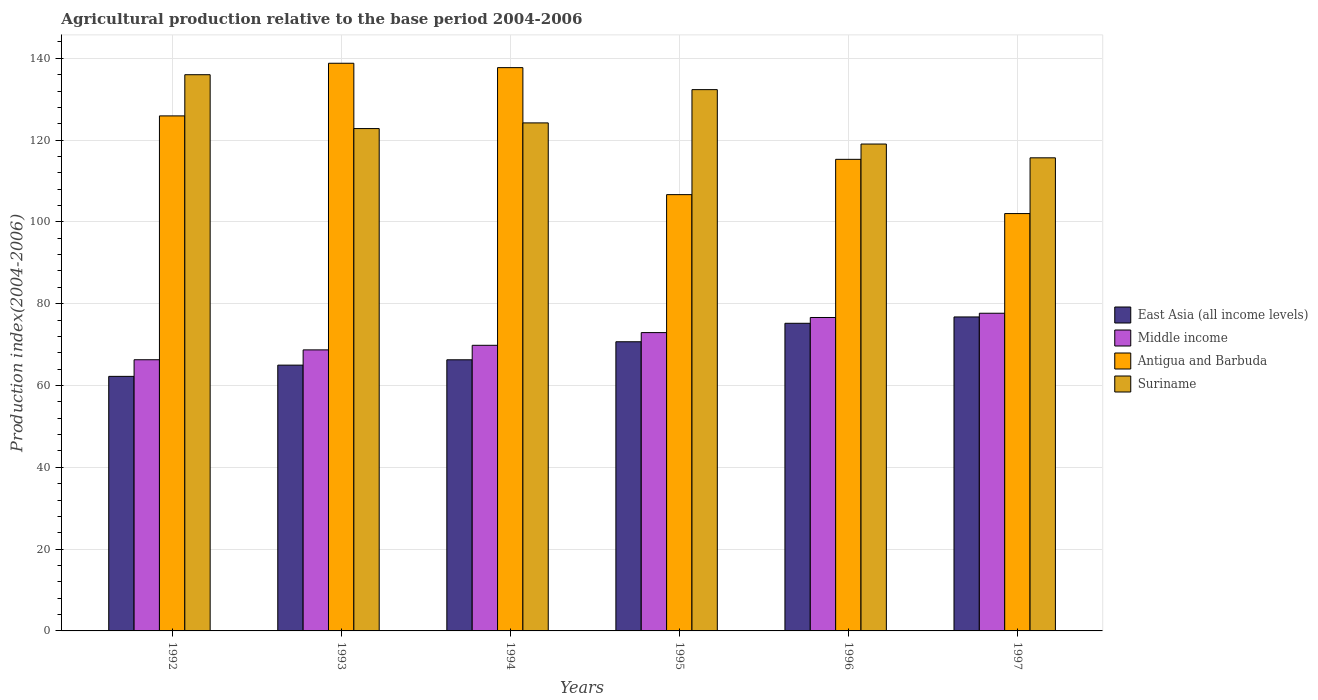How many different coloured bars are there?
Provide a succinct answer. 4. Are the number of bars on each tick of the X-axis equal?
Your response must be concise. Yes. How many bars are there on the 5th tick from the right?
Ensure brevity in your answer.  4. In how many cases, is the number of bars for a given year not equal to the number of legend labels?
Your answer should be compact. 0. What is the agricultural production index in Suriname in 1995?
Make the answer very short. 132.34. Across all years, what is the maximum agricultural production index in Antigua and Barbuda?
Offer a very short reply. 138.79. Across all years, what is the minimum agricultural production index in Antigua and Barbuda?
Keep it short and to the point. 102.04. In which year was the agricultural production index in Antigua and Barbuda maximum?
Ensure brevity in your answer.  1993. In which year was the agricultural production index in Antigua and Barbuda minimum?
Keep it short and to the point. 1997. What is the total agricultural production index in Middle income in the graph?
Offer a very short reply. 432.08. What is the difference between the agricultural production index in Suriname in 1993 and that in 1994?
Give a very brief answer. -1.39. What is the difference between the agricultural production index in East Asia (all income levels) in 1993 and the agricultural production index in Middle income in 1997?
Offer a very short reply. -12.69. What is the average agricultural production index in Middle income per year?
Offer a terse response. 72.01. In the year 1996, what is the difference between the agricultural production index in Suriname and agricultural production index in East Asia (all income levels)?
Ensure brevity in your answer.  43.83. In how many years, is the agricultural production index in East Asia (all income levels) greater than 8?
Your response must be concise. 6. What is the ratio of the agricultural production index in East Asia (all income levels) in 1992 to that in 1996?
Provide a succinct answer. 0.83. Is the difference between the agricultural production index in Suriname in 1994 and 1996 greater than the difference between the agricultural production index in East Asia (all income levels) in 1994 and 1996?
Offer a terse response. Yes. What is the difference between the highest and the second highest agricultural production index in Middle income?
Offer a terse response. 1.04. What is the difference between the highest and the lowest agricultural production index in East Asia (all income levels)?
Ensure brevity in your answer.  14.53. What does the 1st bar from the left in 1997 represents?
Provide a short and direct response. East Asia (all income levels). What does the 4th bar from the right in 1993 represents?
Offer a very short reply. East Asia (all income levels). How many bars are there?
Make the answer very short. 24. Does the graph contain grids?
Give a very brief answer. Yes. How many legend labels are there?
Give a very brief answer. 4. What is the title of the graph?
Provide a succinct answer. Agricultural production relative to the base period 2004-2006. What is the label or title of the Y-axis?
Offer a terse response. Production index(2004-2006). What is the Production index(2004-2006) in East Asia (all income levels) in 1992?
Provide a short and direct response. 62.24. What is the Production index(2004-2006) in Middle income in 1992?
Offer a terse response. 66.3. What is the Production index(2004-2006) of Antigua and Barbuda in 1992?
Ensure brevity in your answer.  125.92. What is the Production index(2004-2006) in Suriname in 1992?
Offer a very short reply. 135.99. What is the Production index(2004-2006) of East Asia (all income levels) in 1993?
Provide a succinct answer. 64.98. What is the Production index(2004-2006) in Middle income in 1993?
Offer a terse response. 68.71. What is the Production index(2004-2006) of Antigua and Barbuda in 1993?
Ensure brevity in your answer.  138.79. What is the Production index(2004-2006) of Suriname in 1993?
Your answer should be compact. 122.82. What is the Production index(2004-2006) in East Asia (all income levels) in 1994?
Offer a very short reply. 66.29. What is the Production index(2004-2006) in Middle income in 1994?
Keep it short and to the point. 69.83. What is the Production index(2004-2006) in Antigua and Barbuda in 1994?
Your answer should be compact. 137.72. What is the Production index(2004-2006) of Suriname in 1994?
Your answer should be compact. 124.21. What is the Production index(2004-2006) in East Asia (all income levels) in 1995?
Your answer should be very brief. 70.7. What is the Production index(2004-2006) of Middle income in 1995?
Your answer should be very brief. 72.94. What is the Production index(2004-2006) of Antigua and Barbuda in 1995?
Provide a short and direct response. 106.67. What is the Production index(2004-2006) in Suriname in 1995?
Keep it short and to the point. 132.34. What is the Production index(2004-2006) of East Asia (all income levels) in 1996?
Your response must be concise. 75.21. What is the Production index(2004-2006) of Middle income in 1996?
Offer a terse response. 76.63. What is the Production index(2004-2006) in Antigua and Barbuda in 1996?
Provide a succinct answer. 115.3. What is the Production index(2004-2006) of Suriname in 1996?
Provide a short and direct response. 119.04. What is the Production index(2004-2006) of East Asia (all income levels) in 1997?
Provide a succinct answer. 76.76. What is the Production index(2004-2006) of Middle income in 1997?
Keep it short and to the point. 77.67. What is the Production index(2004-2006) of Antigua and Barbuda in 1997?
Offer a terse response. 102.04. What is the Production index(2004-2006) of Suriname in 1997?
Offer a very short reply. 115.67. Across all years, what is the maximum Production index(2004-2006) in East Asia (all income levels)?
Provide a short and direct response. 76.76. Across all years, what is the maximum Production index(2004-2006) of Middle income?
Provide a short and direct response. 77.67. Across all years, what is the maximum Production index(2004-2006) in Antigua and Barbuda?
Your answer should be very brief. 138.79. Across all years, what is the maximum Production index(2004-2006) in Suriname?
Your answer should be very brief. 135.99. Across all years, what is the minimum Production index(2004-2006) in East Asia (all income levels)?
Your response must be concise. 62.24. Across all years, what is the minimum Production index(2004-2006) of Middle income?
Your answer should be very brief. 66.3. Across all years, what is the minimum Production index(2004-2006) in Antigua and Barbuda?
Your answer should be compact. 102.04. Across all years, what is the minimum Production index(2004-2006) in Suriname?
Your answer should be compact. 115.67. What is the total Production index(2004-2006) of East Asia (all income levels) in the graph?
Your answer should be compact. 416.18. What is the total Production index(2004-2006) in Middle income in the graph?
Your response must be concise. 432.08. What is the total Production index(2004-2006) of Antigua and Barbuda in the graph?
Provide a succinct answer. 726.44. What is the total Production index(2004-2006) in Suriname in the graph?
Offer a terse response. 750.07. What is the difference between the Production index(2004-2006) in East Asia (all income levels) in 1992 and that in 1993?
Give a very brief answer. -2.75. What is the difference between the Production index(2004-2006) of Middle income in 1992 and that in 1993?
Ensure brevity in your answer.  -2.41. What is the difference between the Production index(2004-2006) in Antigua and Barbuda in 1992 and that in 1993?
Give a very brief answer. -12.87. What is the difference between the Production index(2004-2006) in Suriname in 1992 and that in 1993?
Keep it short and to the point. 13.17. What is the difference between the Production index(2004-2006) of East Asia (all income levels) in 1992 and that in 1994?
Your answer should be very brief. -4.05. What is the difference between the Production index(2004-2006) in Middle income in 1992 and that in 1994?
Provide a short and direct response. -3.53. What is the difference between the Production index(2004-2006) in Suriname in 1992 and that in 1994?
Ensure brevity in your answer.  11.78. What is the difference between the Production index(2004-2006) in East Asia (all income levels) in 1992 and that in 1995?
Make the answer very short. -8.46. What is the difference between the Production index(2004-2006) of Middle income in 1992 and that in 1995?
Offer a terse response. -6.64. What is the difference between the Production index(2004-2006) in Antigua and Barbuda in 1992 and that in 1995?
Provide a short and direct response. 19.25. What is the difference between the Production index(2004-2006) in Suriname in 1992 and that in 1995?
Offer a terse response. 3.65. What is the difference between the Production index(2004-2006) of East Asia (all income levels) in 1992 and that in 1996?
Make the answer very short. -12.98. What is the difference between the Production index(2004-2006) in Middle income in 1992 and that in 1996?
Keep it short and to the point. -10.33. What is the difference between the Production index(2004-2006) in Antigua and Barbuda in 1992 and that in 1996?
Provide a succinct answer. 10.62. What is the difference between the Production index(2004-2006) of Suriname in 1992 and that in 1996?
Provide a short and direct response. 16.95. What is the difference between the Production index(2004-2006) of East Asia (all income levels) in 1992 and that in 1997?
Make the answer very short. -14.53. What is the difference between the Production index(2004-2006) in Middle income in 1992 and that in 1997?
Offer a terse response. -11.37. What is the difference between the Production index(2004-2006) in Antigua and Barbuda in 1992 and that in 1997?
Provide a short and direct response. 23.88. What is the difference between the Production index(2004-2006) of Suriname in 1992 and that in 1997?
Make the answer very short. 20.32. What is the difference between the Production index(2004-2006) in East Asia (all income levels) in 1993 and that in 1994?
Make the answer very short. -1.3. What is the difference between the Production index(2004-2006) of Middle income in 1993 and that in 1994?
Provide a succinct answer. -1.12. What is the difference between the Production index(2004-2006) of Antigua and Barbuda in 1993 and that in 1994?
Ensure brevity in your answer.  1.07. What is the difference between the Production index(2004-2006) in Suriname in 1993 and that in 1994?
Make the answer very short. -1.39. What is the difference between the Production index(2004-2006) in East Asia (all income levels) in 1993 and that in 1995?
Your answer should be very brief. -5.71. What is the difference between the Production index(2004-2006) of Middle income in 1993 and that in 1995?
Your answer should be compact. -4.22. What is the difference between the Production index(2004-2006) of Antigua and Barbuda in 1993 and that in 1995?
Provide a succinct answer. 32.12. What is the difference between the Production index(2004-2006) of Suriname in 1993 and that in 1995?
Your answer should be compact. -9.52. What is the difference between the Production index(2004-2006) in East Asia (all income levels) in 1993 and that in 1996?
Your answer should be very brief. -10.23. What is the difference between the Production index(2004-2006) in Middle income in 1993 and that in 1996?
Offer a terse response. -7.92. What is the difference between the Production index(2004-2006) of Antigua and Barbuda in 1993 and that in 1996?
Give a very brief answer. 23.49. What is the difference between the Production index(2004-2006) of Suriname in 1993 and that in 1996?
Your response must be concise. 3.78. What is the difference between the Production index(2004-2006) in East Asia (all income levels) in 1993 and that in 1997?
Provide a succinct answer. -11.78. What is the difference between the Production index(2004-2006) in Middle income in 1993 and that in 1997?
Offer a terse response. -8.96. What is the difference between the Production index(2004-2006) of Antigua and Barbuda in 1993 and that in 1997?
Your answer should be very brief. 36.75. What is the difference between the Production index(2004-2006) in Suriname in 1993 and that in 1997?
Ensure brevity in your answer.  7.15. What is the difference between the Production index(2004-2006) in East Asia (all income levels) in 1994 and that in 1995?
Provide a short and direct response. -4.41. What is the difference between the Production index(2004-2006) in Middle income in 1994 and that in 1995?
Ensure brevity in your answer.  -3.11. What is the difference between the Production index(2004-2006) of Antigua and Barbuda in 1994 and that in 1995?
Your answer should be compact. 31.05. What is the difference between the Production index(2004-2006) of Suriname in 1994 and that in 1995?
Make the answer very short. -8.13. What is the difference between the Production index(2004-2006) in East Asia (all income levels) in 1994 and that in 1996?
Keep it short and to the point. -8.93. What is the difference between the Production index(2004-2006) of Middle income in 1994 and that in 1996?
Provide a succinct answer. -6.8. What is the difference between the Production index(2004-2006) of Antigua and Barbuda in 1994 and that in 1996?
Ensure brevity in your answer.  22.42. What is the difference between the Production index(2004-2006) in Suriname in 1994 and that in 1996?
Your response must be concise. 5.17. What is the difference between the Production index(2004-2006) in East Asia (all income levels) in 1994 and that in 1997?
Your answer should be very brief. -10.47. What is the difference between the Production index(2004-2006) in Middle income in 1994 and that in 1997?
Offer a very short reply. -7.84. What is the difference between the Production index(2004-2006) in Antigua and Barbuda in 1994 and that in 1997?
Keep it short and to the point. 35.68. What is the difference between the Production index(2004-2006) in Suriname in 1994 and that in 1997?
Offer a very short reply. 8.54. What is the difference between the Production index(2004-2006) of East Asia (all income levels) in 1995 and that in 1996?
Make the answer very short. -4.52. What is the difference between the Production index(2004-2006) in Middle income in 1995 and that in 1996?
Provide a short and direct response. -3.69. What is the difference between the Production index(2004-2006) of Antigua and Barbuda in 1995 and that in 1996?
Ensure brevity in your answer.  -8.63. What is the difference between the Production index(2004-2006) in East Asia (all income levels) in 1995 and that in 1997?
Provide a succinct answer. -6.07. What is the difference between the Production index(2004-2006) of Middle income in 1995 and that in 1997?
Ensure brevity in your answer.  -4.73. What is the difference between the Production index(2004-2006) in Antigua and Barbuda in 1995 and that in 1997?
Your answer should be very brief. 4.63. What is the difference between the Production index(2004-2006) of Suriname in 1995 and that in 1997?
Make the answer very short. 16.67. What is the difference between the Production index(2004-2006) of East Asia (all income levels) in 1996 and that in 1997?
Your response must be concise. -1.55. What is the difference between the Production index(2004-2006) in Middle income in 1996 and that in 1997?
Your answer should be compact. -1.04. What is the difference between the Production index(2004-2006) in Antigua and Barbuda in 1996 and that in 1997?
Your answer should be compact. 13.26. What is the difference between the Production index(2004-2006) of Suriname in 1996 and that in 1997?
Offer a very short reply. 3.37. What is the difference between the Production index(2004-2006) of East Asia (all income levels) in 1992 and the Production index(2004-2006) of Middle income in 1993?
Provide a short and direct response. -6.48. What is the difference between the Production index(2004-2006) of East Asia (all income levels) in 1992 and the Production index(2004-2006) of Antigua and Barbuda in 1993?
Give a very brief answer. -76.55. What is the difference between the Production index(2004-2006) of East Asia (all income levels) in 1992 and the Production index(2004-2006) of Suriname in 1993?
Your response must be concise. -60.58. What is the difference between the Production index(2004-2006) of Middle income in 1992 and the Production index(2004-2006) of Antigua and Barbuda in 1993?
Ensure brevity in your answer.  -72.49. What is the difference between the Production index(2004-2006) in Middle income in 1992 and the Production index(2004-2006) in Suriname in 1993?
Ensure brevity in your answer.  -56.52. What is the difference between the Production index(2004-2006) in Antigua and Barbuda in 1992 and the Production index(2004-2006) in Suriname in 1993?
Keep it short and to the point. 3.1. What is the difference between the Production index(2004-2006) of East Asia (all income levels) in 1992 and the Production index(2004-2006) of Middle income in 1994?
Ensure brevity in your answer.  -7.59. What is the difference between the Production index(2004-2006) in East Asia (all income levels) in 1992 and the Production index(2004-2006) in Antigua and Barbuda in 1994?
Keep it short and to the point. -75.48. What is the difference between the Production index(2004-2006) in East Asia (all income levels) in 1992 and the Production index(2004-2006) in Suriname in 1994?
Ensure brevity in your answer.  -61.97. What is the difference between the Production index(2004-2006) in Middle income in 1992 and the Production index(2004-2006) in Antigua and Barbuda in 1994?
Offer a very short reply. -71.42. What is the difference between the Production index(2004-2006) of Middle income in 1992 and the Production index(2004-2006) of Suriname in 1994?
Ensure brevity in your answer.  -57.91. What is the difference between the Production index(2004-2006) in Antigua and Barbuda in 1992 and the Production index(2004-2006) in Suriname in 1994?
Make the answer very short. 1.71. What is the difference between the Production index(2004-2006) of East Asia (all income levels) in 1992 and the Production index(2004-2006) of Middle income in 1995?
Provide a succinct answer. -10.7. What is the difference between the Production index(2004-2006) of East Asia (all income levels) in 1992 and the Production index(2004-2006) of Antigua and Barbuda in 1995?
Provide a succinct answer. -44.43. What is the difference between the Production index(2004-2006) in East Asia (all income levels) in 1992 and the Production index(2004-2006) in Suriname in 1995?
Your answer should be very brief. -70.1. What is the difference between the Production index(2004-2006) of Middle income in 1992 and the Production index(2004-2006) of Antigua and Barbuda in 1995?
Give a very brief answer. -40.37. What is the difference between the Production index(2004-2006) of Middle income in 1992 and the Production index(2004-2006) of Suriname in 1995?
Ensure brevity in your answer.  -66.04. What is the difference between the Production index(2004-2006) in Antigua and Barbuda in 1992 and the Production index(2004-2006) in Suriname in 1995?
Your answer should be very brief. -6.42. What is the difference between the Production index(2004-2006) in East Asia (all income levels) in 1992 and the Production index(2004-2006) in Middle income in 1996?
Provide a short and direct response. -14.39. What is the difference between the Production index(2004-2006) in East Asia (all income levels) in 1992 and the Production index(2004-2006) in Antigua and Barbuda in 1996?
Offer a very short reply. -53.06. What is the difference between the Production index(2004-2006) of East Asia (all income levels) in 1992 and the Production index(2004-2006) of Suriname in 1996?
Keep it short and to the point. -56.8. What is the difference between the Production index(2004-2006) in Middle income in 1992 and the Production index(2004-2006) in Antigua and Barbuda in 1996?
Keep it short and to the point. -49. What is the difference between the Production index(2004-2006) in Middle income in 1992 and the Production index(2004-2006) in Suriname in 1996?
Provide a short and direct response. -52.74. What is the difference between the Production index(2004-2006) of Antigua and Barbuda in 1992 and the Production index(2004-2006) of Suriname in 1996?
Offer a very short reply. 6.88. What is the difference between the Production index(2004-2006) of East Asia (all income levels) in 1992 and the Production index(2004-2006) of Middle income in 1997?
Keep it short and to the point. -15.44. What is the difference between the Production index(2004-2006) of East Asia (all income levels) in 1992 and the Production index(2004-2006) of Antigua and Barbuda in 1997?
Provide a succinct answer. -39.8. What is the difference between the Production index(2004-2006) of East Asia (all income levels) in 1992 and the Production index(2004-2006) of Suriname in 1997?
Your response must be concise. -53.43. What is the difference between the Production index(2004-2006) of Middle income in 1992 and the Production index(2004-2006) of Antigua and Barbuda in 1997?
Give a very brief answer. -35.74. What is the difference between the Production index(2004-2006) in Middle income in 1992 and the Production index(2004-2006) in Suriname in 1997?
Your response must be concise. -49.37. What is the difference between the Production index(2004-2006) of Antigua and Barbuda in 1992 and the Production index(2004-2006) of Suriname in 1997?
Provide a short and direct response. 10.25. What is the difference between the Production index(2004-2006) of East Asia (all income levels) in 1993 and the Production index(2004-2006) of Middle income in 1994?
Your answer should be very brief. -4.85. What is the difference between the Production index(2004-2006) in East Asia (all income levels) in 1993 and the Production index(2004-2006) in Antigua and Barbuda in 1994?
Offer a very short reply. -72.74. What is the difference between the Production index(2004-2006) in East Asia (all income levels) in 1993 and the Production index(2004-2006) in Suriname in 1994?
Your response must be concise. -59.23. What is the difference between the Production index(2004-2006) of Middle income in 1993 and the Production index(2004-2006) of Antigua and Barbuda in 1994?
Make the answer very short. -69.01. What is the difference between the Production index(2004-2006) of Middle income in 1993 and the Production index(2004-2006) of Suriname in 1994?
Make the answer very short. -55.5. What is the difference between the Production index(2004-2006) in Antigua and Barbuda in 1993 and the Production index(2004-2006) in Suriname in 1994?
Offer a terse response. 14.58. What is the difference between the Production index(2004-2006) in East Asia (all income levels) in 1993 and the Production index(2004-2006) in Middle income in 1995?
Provide a succinct answer. -7.95. What is the difference between the Production index(2004-2006) in East Asia (all income levels) in 1993 and the Production index(2004-2006) in Antigua and Barbuda in 1995?
Make the answer very short. -41.69. What is the difference between the Production index(2004-2006) in East Asia (all income levels) in 1993 and the Production index(2004-2006) in Suriname in 1995?
Offer a terse response. -67.36. What is the difference between the Production index(2004-2006) in Middle income in 1993 and the Production index(2004-2006) in Antigua and Barbuda in 1995?
Give a very brief answer. -37.96. What is the difference between the Production index(2004-2006) in Middle income in 1993 and the Production index(2004-2006) in Suriname in 1995?
Offer a terse response. -63.63. What is the difference between the Production index(2004-2006) of Antigua and Barbuda in 1993 and the Production index(2004-2006) of Suriname in 1995?
Ensure brevity in your answer.  6.45. What is the difference between the Production index(2004-2006) in East Asia (all income levels) in 1993 and the Production index(2004-2006) in Middle income in 1996?
Your answer should be very brief. -11.65. What is the difference between the Production index(2004-2006) in East Asia (all income levels) in 1993 and the Production index(2004-2006) in Antigua and Barbuda in 1996?
Offer a very short reply. -50.32. What is the difference between the Production index(2004-2006) of East Asia (all income levels) in 1993 and the Production index(2004-2006) of Suriname in 1996?
Offer a very short reply. -54.06. What is the difference between the Production index(2004-2006) of Middle income in 1993 and the Production index(2004-2006) of Antigua and Barbuda in 1996?
Ensure brevity in your answer.  -46.59. What is the difference between the Production index(2004-2006) in Middle income in 1993 and the Production index(2004-2006) in Suriname in 1996?
Provide a short and direct response. -50.33. What is the difference between the Production index(2004-2006) in Antigua and Barbuda in 1993 and the Production index(2004-2006) in Suriname in 1996?
Provide a succinct answer. 19.75. What is the difference between the Production index(2004-2006) of East Asia (all income levels) in 1993 and the Production index(2004-2006) of Middle income in 1997?
Provide a succinct answer. -12.69. What is the difference between the Production index(2004-2006) in East Asia (all income levels) in 1993 and the Production index(2004-2006) in Antigua and Barbuda in 1997?
Your response must be concise. -37.06. What is the difference between the Production index(2004-2006) of East Asia (all income levels) in 1993 and the Production index(2004-2006) of Suriname in 1997?
Keep it short and to the point. -50.69. What is the difference between the Production index(2004-2006) in Middle income in 1993 and the Production index(2004-2006) in Antigua and Barbuda in 1997?
Offer a very short reply. -33.33. What is the difference between the Production index(2004-2006) in Middle income in 1993 and the Production index(2004-2006) in Suriname in 1997?
Offer a very short reply. -46.96. What is the difference between the Production index(2004-2006) of Antigua and Barbuda in 1993 and the Production index(2004-2006) of Suriname in 1997?
Make the answer very short. 23.12. What is the difference between the Production index(2004-2006) of East Asia (all income levels) in 1994 and the Production index(2004-2006) of Middle income in 1995?
Keep it short and to the point. -6.65. What is the difference between the Production index(2004-2006) in East Asia (all income levels) in 1994 and the Production index(2004-2006) in Antigua and Barbuda in 1995?
Your answer should be compact. -40.38. What is the difference between the Production index(2004-2006) in East Asia (all income levels) in 1994 and the Production index(2004-2006) in Suriname in 1995?
Keep it short and to the point. -66.05. What is the difference between the Production index(2004-2006) of Middle income in 1994 and the Production index(2004-2006) of Antigua and Barbuda in 1995?
Provide a short and direct response. -36.84. What is the difference between the Production index(2004-2006) of Middle income in 1994 and the Production index(2004-2006) of Suriname in 1995?
Make the answer very short. -62.51. What is the difference between the Production index(2004-2006) in Antigua and Barbuda in 1994 and the Production index(2004-2006) in Suriname in 1995?
Your response must be concise. 5.38. What is the difference between the Production index(2004-2006) of East Asia (all income levels) in 1994 and the Production index(2004-2006) of Middle income in 1996?
Ensure brevity in your answer.  -10.34. What is the difference between the Production index(2004-2006) of East Asia (all income levels) in 1994 and the Production index(2004-2006) of Antigua and Barbuda in 1996?
Ensure brevity in your answer.  -49.01. What is the difference between the Production index(2004-2006) in East Asia (all income levels) in 1994 and the Production index(2004-2006) in Suriname in 1996?
Offer a terse response. -52.75. What is the difference between the Production index(2004-2006) in Middle income in 1994 and the Production index(2004-2006) in Antigua and Barbuda in 1996?
Your answer should be very brief. -45.47. What is the difference between the Production index(2004-2006) of Middle income in 1994 and the Production index(2004-2006) of Suriname in 1996?
Offer a very short reply. -49.21. What is the difference between the Production index(2004-2006) of Antigua and Barbuda in 1994 and the Production index(2004-2006) of Suriname in 1996?
Provide a succinct answer. 18.68. What is the difference between the Production index(2004-2006) in East Asia (all income levels) in 1994 and the Production index(2004-2006) in Middle income in 1997?
Offer a very short reply. -11.38. What is the difference between the Production index(2004-2006) in East Asia (all income levels) in 1994 and the Production index(2004-2006) in Antigua and Barbuda in 1997?
Your answer should be compact. -35.75. What is the difference between the Production index(2004-2006) in East Asia (all income levels) in 1994 and the Production index(2004-2006) in Suriname in 1997?
Provide a succinct answer. -49.38. What is the difference between the Production index(2004-2006) in Middle income in 1994 and the Production index(2004-2006) in Antigua and Barbuda in 1997?
Make the answer very short. -32.21. What is the difference between the Production index(2004-2006) of Middle income in 1994 and the Production index(2004-2006) of Suriname in 1997?
Provide a succinct answer. -45.84. What is the difference between the Production index(2004-2006) of Antigua and Barbuda in 1994 and the Production index(2004-2006) of Suriname in 1997?
Your answer should be compact. 22.05. What is the difference between the Production index(2004-2006) in East Asia (all income levels) in 1995 and the Production index(2004-2006) in Middle income in 1996?
Make the answer very short. -5.93. What is the difference between the Production index(2004-2006) in East Asia (all income levels) in 1995 and the Production index(2004-2006) in Antigua and Barbuda in 1996?
Make the answer very short. -44.6. What is the difference between the Production index(2004-2006) in East Asia (all income levels) in 1995 and the Production index(2004-2006) in Suriname in 1996?
Keep it short and to the point. -48.34. What is the difference between the Production index(2004-2006) in Middle income in 1995 and the Production index(2004-2006) in Antigua and Barbuda in 1996?
Your response must be concise. -42.36. What is the difference between the Production index(2004-2006) in Middle income in 1995 and the Production index(2004-2006) in Suriname in 1996?
Keep it short and to the point. -46.1. What is the difference between the Production index(2004-2006) in Antigua and Barbuda in 1995 and the Production index(2004-2006) in Suriname in 1996?
Make the answer very short. -12.37. What is the difference between the Production index(2004-2006) of East Asia (all income levels) in 1995 and the Production index(2004-2006) of Middle income in 1997?
Provide a short and direct response. -6.97. What is the difference between the Production index(2004-2006) in East Asia (all income levels) in 1995 and the Production index(2004-2006) in Antigua and Barbuda in 1997?
Make the answer very short. -31.34. What is the difference between the Production index(2004-2006) of East Asia (all income levels) in 1995 and the Production index(2004-2006) of Suriname in 1997?
Your answer should be compact. -44.97. What is the difference between the Production index(2004-2006) of Middle income in 1995 and the Production index(2004-2006) of Antigua and Barbuda in 1997?
Provide a short and direct response. -29.1. What is the difference between the Production index(2004-2006) of Middle income in 1995 and the Production index(2004-2006) of Suriname in 1997?
Ensure brevity in your answer.  -42.73. What is the difference between the Production index(2004-2006) of East Asia (all income levels) in 1996 and the Production index(2004-2006) of Middle income in 1997?
Make the answer very short. -2.46. What is the difference between the Production index(2004-2006) in East Asia (all income levels) in 1996 and the Production index(2004-2006) in Antigua and Barbuda in 1997?
Provide a short and direct response. -26.83. What is the difference between the Production index(2004-2006) in East Asia (all income levels) in 1996 and the Production index(2004-2006) in Suriname in 1997?
Your answer should be very brief. -40.46. What is the difference between the Production index(2004-2006) in Middle income in 1996 and the Production index(2004-2006) in Antigua and Barbuda in 1997?
Your answer should be very brief. -25.41. What is the difference between the Production index(2004-2006) in Middle income in 1996 and the Production index(2004-2006) in Suriname in 1997?
Provide a succinct answer. -39.04. What is the difference between the Production index(2004-2006) in Antigua and Barbuda in 1996 and the Production index(2004-2006) in Suriname in 1997?
Provide a succinct answer. -0.37. What is the average Production index(2004-2006) of East Asia (all income levels) per year?
Your answer should be very brief. 69.36. What is the average Production index(2004-2006) of Middle income per year?
Your answer should be very brief. 72.01. What is the average Production index(2004-2006) of Antigua and Barbuda per year?
Your answer should be compact. 121.07. What is the average Production index(2004-2006) of Suriname per year?
Offer a terse response. 125.01. In the year 1992, what is the difference between the Production index(2004-2006) in East Asia (all income levels) and Production index(2004-2006) in Middle income?
Give a very brief answer. -4.07. In the year 1992, what is the difference between the Production index(2004-2006) of East Asia (all income levels) and Production index(2004-2006) of Antigua and Barbuda?
Provide a short and direct response. -63.68. In the year 1992, what is the difference between the Production index(2004-2006) of East Asia (all income levels) and Production index(2004-2006) of Suriname?
Offer a very short reply. -73.75. In the year 1992, what is the difference between the Production index(2004-2006) of Middle income and Production index(2004-2006) of Antigua and Barbuda?
Provide a succinct answer. -59.62. In the year 1992, what is the difference between the Production index(2004-2006) in Middle income and Production index(2004-2006) in Suriname?
Ensure brevity in your answer.  -69.69. In the year 1992, what is the difference between the Production index(2004-2006) of Antigua and Barbuda and Production index(2004-2006) of Suriname?
Provide a short and direct response. -10.07. In the year 1993, what is the difference between the Production index(2004-2006) in East Asia (all income levels) and Production index(2004-2006) in Middle income?
Your response must be concise. -3.73. In the year 1993, what is the difference between the Production index(2004-2006) of East Asia (all income levels) and Production index(2004-2006) of Antigua and Barbuda?
Give a very brief answer. -73.81. In the year 1993, what is the difference between the Production index(2004-2006) of East Asia (all income levels) and Production index(2004-2006) of Suriname?
Your answer should be very brief. -57.84. In the year 1993, what is the difference between the Production index(2004-2006) of Middle income and Production index(2004-2006) of Antigua and Barbuda?
Give a very brief answer. -70.08. In the year 1993, what is the difference between the Production index(2004-2006) in Middle income and Production index(2004-2006) in Suriname?
Offer a terse response. -54.11. In the year 1993, what is the difference between the Production index(2004-2006) in Antigua and Barbuda and Production index(2004-2006) in Suriname?
Keep it short and to the point. 15.97. In the year 1994, what is the difference between the Production index(2004-2006) in East Asia (all income levels) and Production index(2004-2006) in Middle income?
Provide a short and direct response. -3.54. In the year 1994, what is the difference between the Production index(2004-2006) of East Asia (all income levels) and Production index(2004-2006) of Antigua and Barbuda?
Give a very brief answer. -71.43. In the year 1994, what is the difference between the Production index(2004-2006) of East Asia (all income levels) and Production index(2004-2006) of Suriname?
Offer a terse response. -57.92. In the year 1994, what is the difference between the Production index(2004-2006) in Middle income and Production index(2004-2006) in Antigua and Barbuda?
Give a very brief answer. -67.89. In the year 1994, what is the difference between the Production index(2004-2006) in Middle income and Production index(2004-2006) in Suriname?
Keep it short and to the point. -54.38. In the year 1994, what is the difference between the Production index(2004-2006) in Antigua and Barbuda and Production index(2004-2006) in Suriname?
Provide a succinct answer. 13.51. In the year 1995, what is the difference between the Production index(2004-2006) in East Asia (all income levels) and Production index(2004-2006) in Middle income?
Provide a short and direct response. -2.24. In the year 1995, what is the difference between the Production index(2004-2006) in East Asia (all income levels) and Production index(2004-2006) in Antigua and Barbuda?
Provide a short and direct response. -35.97. In the year 1995, what is the difference between the Production index(2004-2006) in East Asia (all income levels) and Production index(2004-2006) in Suriname?
Offer a terse response. -61.64. In the year 1995, what is the difference between the Production index(2004-2006) of Middle income and Production index(2004-2006) of Antigua and Barbuda?
Keep it short and to the point. -33.73. In the year 1995, what is the difference between the Production index(2004-2006) in Middle income and Production index(2004-2006) in Suriname?
Ensure brevity in your answer.  -59.4. In the year 1995, what is the difference between the Production index(2004-2006) in Antigua and Barbuda and Production index(2004-2006) in Suriname?
Your answer should be very brief. -25.67. In the year 1996, what is the difference between the Production index(2004-2006) in East Asia (all income levels) and Production index(2004-2006) in Middle income?
Provide a short and direct response. -1.42. In the year 1996, what is the difference between the Production index(2004-2006) in East Asia (all income levels) and Production index(2004-2006) in Antigua and Barbuda?
Keep it short and to the point. -40.09. In the year 1996, what is the difference between the Production index(2004-2006) in East Asia (all income levels) and Production index(2004-2006) in Suriname?
Offer a terse response. -43.83. In the year 1996, what is the difference between the Production index(2004-2006) in Middle income and Production index(2004-2006) in Antigua and Barbuda?
Provide a short and direct response. -38.67. In the year 1996, what is the difference between the Production index(2004-2006) in Middle income and Production index(2004-2006) in Suriname?
Give a very brief answer. -42.41. In the year 1996, what is the difference between the Production index(2004-2006) of Antigua and Barbuda and Production index(2004-2006) of Suriname?
Your answer should be compact. -3.74. In the year 1997, what is the difference between the Production index(2004-2006) in East Asia (all income levels) and Production index(2004-2006) in Middle income?
Your answer should be compact. -0.91. In the year 1997, what is the difference between the Production index(2004-2006) in East Asia (all income levels) and Production index(2004-2006) in Antigua and Barbuda?
Make the answer very short. -25.28. In the year 1997, what is the difference between the Production index(2004-2006) of East Asia (all income levels) and Production index(2004-2006) of Suriname?
Make the answer very short. -38.91. In the year 1997, what is the difference between the Production index(2004-2006) in Middle income and Production index(2004-2006) in Antigua and Barbuda?
Offer a very short reply. -24.37. In the year 1997, what is the difference between the Production index(2004-2006) of Middle income and Production index(2004-2006) of Suriname?
Your answer should be very brief. -38. In the year 1997, what is the difference between the Production index(2004-2006) of Antigua and Barbuda and Production index(2004-2006) of Suriname?
Offer a very short reply. -13.63. What is the ratio of the Production index(2004-2006) in East Asia (all income levels) in 1992 to that in 1993?
Your response must be concise. 0.96. What is the ratio of the Production index(2004-2006) in Middle income in 1992 to that in 1993?
Your answer should be compact. 0.96. What is the ratio of the Production index(2004-2006) in Antigua and Barbuda in 1992 to that in 1993?
Offer a very short reply. 0.91. What is the ratio of the Production index(2004-2006) of Suriname in 1992 to that in 1993?
Provide a succinct answer. 1.11. What is the ratio of the Production index(2004-2006) of East Asia (all income levels) in 1992 to that in 1994?
Ensure brevity in your answer.  0.94. What is the ratio of the Production index(2004-2006) of Middle income in 1992 to that in 1994?
Your answer should be compact. 0.95. What is the ratio of the Production index(2004-2006) of Antigua and Barbuda in 1992 to that in 1994?
Your answer should be compact. 0.91. What is the ratio of the Production index(2004-2006) in Suriname in 1992 to that in 1994?
Give a very brief answer. 1.09. What is the ratio of the Production index(2004-2006) of East Asia (all income levels) in 1992 to that in 1995?
Ensure brevity in your answer.  0.88. What is the ratio of the Production index(2004-2006) of Middle income in 1992 to that in 1995?
Your response must be concise. 0.91. What is the ratio of the Production index(2004-2006) in Antigua and Barbuda in 1992 to that in 1995?
Your answer should be very brief. 1.18. What is the ratio of the Production index(2004-2006) of Suriname in 1992 to that in 1995?
Make the answer very short. 1.03. What is the ratio of the Production index(2004-2006) in East Asia (all income levels) in 1992 to that in 1996?
Your answer should be very brief. 0.83. What is the ratio of the Production index(2004-2006) in Middle income in 1992 to that in 1996?
Your response must be concise. 0.87. What is the ratio of the Production index(2004-2006) in Antigua and Barbuda in 1992 to that in 1996?
Provide a succinct answer. 1.09. What is the ratio of the Production index(2004-2006) in Suriname in 1992 to that in 1996?
Offer a terse response. 1.14. What is the ratio of the Production index(2004-2006) in East Asia (all income levels) in 1992 to that in 1997?
Ensure brevity in your answer.  0.81. What is the ratio of the Production index(2004-2006) in Middle income in 1992 to that in 1997?
Offer a terse response. 0.85. What is the ratio of the Production index(2004-2006) in Antigua and Barbuda in 1992 to that in 1997?
Provide a short and direct response. 1.23. What is the ratio of the Production index(2004-2006) in Suriname in 1992 to that in 1997?
Your answer should be very brief. 1.18. What is the ratio of the Production index(2004-2006) in East Asia (all income levels) in 1993 to that in 1994?
Keep it short and to the point. 0.98. What is the ratio of the Production index(2004-2006) in Antigua and Barbuda in 1993 to that in 1994?
Make the answer very short. 1.01. What is the ratio of the Production index(2004-2006) of East Asia (all income levels) in 1993 to that in 1995?
Offer a terse response. 0.92. What is the ratio of the Production index(2004-2006) in Middle income in 1993 to that in 1995?
Provide a short and direct response. 0.94. What is the ratio of the Production index(2004-2006) in Antigua and Barbuda in 1993 to that in 1995?
Offer a very short reply. 1.3. What is the ratio of the Production index(2004-2006) of Suriname in 1993 to that in 1995?
Ensure brevity in your answer.  0.93. What is the ratio of the Production index(2004-2006) in East Asia (all income levels) in 1993 to that in 1996?
Provide a succinct answer. 0.86. What is the ratio of the Production index(2004-2006) in Middle income in 1993 to that in 1996?
Make the answer very short. 0.9. What is the ratio of the Production index(2004-2006) of Antigua and Barbuda in 1993 to that in 1996?
Offer a terse response. 1.2. What is the ratio of the Production index(2004-2006) in Suriname in 1993 to that in 1996?
Give a very brief answer. 1.03. What is the ratio of the Production index(2004-2006) in East Asia (all income levels) in 1993 to that in 1997?
Offer a very short reply. 0.85. What is the ratio of the Production index(2004-2006) of Middle income in 1993 to that in 1997?
Offer a very short reply. 0.88. What is the ratio of the Production index(2004-2006) of Antigua and Barbuda in 1993 to that in 1997?
Provide a short and direct response. 1.36. What is the ratio of the Production index(2004-2006) in Suriname in 1993 to that in 1997?
Provide a short and direct response. 1.06. What is the ratio of the Production index(2004-2006) in East Asia (all income levels) in 1994 to that in 1995?
Ensure brevity in your answer.  0.94. What is the ratio of the Production index(2004-2006) of Middle income in 1994 to that in 1995?
Offer a terse response. 0.96. What is the ratio of the Production index(2004-2006) in Antigua and Barbuda in 1994 to that in 1995?
Make the answer very short. 1.29. What is the ratio of the Production index(2004-2006) in Suriname in 1994 to that in 1995?
Give a very brief answer. 0.94. What is the ratio of the Production index(2004-2006) in East Asia (all income levels) in 1994 to that in 1996?
Keep it short and to the point. 0.88. What is the ratio of the Production index(2004-2006) of Middle income in 1994 to that in 1996?
Provide a short and direct response. 0.91. What is the ratio of the Production index(2004-2006) of Antigua and Barbuda in 1994 to that in 1996?
Make the answer very short. 1.19. What is the ratio of the Production index(2004-2006) in Suriname in 1994 to that in 1996?
Keep it short and to the point. 1.04. What is the ratio of the Production index(2004-2006) of East Asia (all income levels) in 1994 to that in 1997?
Offer a terse response. 0.86. What is the ratio of the Production index(2004-2006) in Middle income in 1994 to that in 1997?
Your answer should be compact. 0.9. What is the ratio of the Production index(2004-2006) in Antigua and Barbuda in 1994 to that in 1997?
Offer a terse response. 1.35. What is the ratio of the Production index(2004-2006) in Suriname in 1994 to that in 1997?
Ensure brevity in your answer.  1.07. What is the ratio of the Production index(2004-2006) in East Asia (all income levels) in 1995 to that in 1996?
Your response must be concise. 0.94. What is the ratio of the Production index(2004-2006) in Middle income in 1995 to that in 1996?
Make the answer very short. 0.95. What is the ratio of the Production index(2004-2006) of Antigua and Barbuda in 1995 to that in 1996?
Your answer should be compact. 0.93. What is the ratio of the Production index(2004-2006) of Suriname in 1995 to that in 1996?
Offer a terse response. 1.11. What is the ratio of the Production index(2004-2006) in East Asia (all income levels) in 1995 to that in 1997?
Offer a terse response. 0.92. What is the ratio of the Production index(2004-2006) in Middle income in 1995 to that in 1997?
Offer a very short reply. 0.94. What is the ratio of the Production index(2004-2006) of Antigua and Barbuda in 1995 to that in 1997?
Your answer should be very brief. 1.05. What is the ratio of the Production index(2004-2006) in Suriname in 1995 to that in 1997?
Ensure brevity in your answer.  1.14. What is the ratio of the Production index(2004-2006) of East Asia (all income levels) in 1996 to that in 1997?
Keep it short and to the point. 0.98. What is the ratio of the Production index(2004-2006) in Middle income in 1996 to that in 1997?
Ensure brevity in your answer.  0.99. What is the ratio of the Production index(2004-2006) in Antigua and Barbuda in 1996 to that in 1997?
Ensure brevity in your answer.  1.13. What is the ratio of the Production index(2004-2006) of Suriname in 1996 to that in 1997?
Provide a short and direct response. 1.03. What is the difference between the highest and the second highest Production index(2004-2006) of East Asia (all income levels)?
Keep it short and to the point. 1.55. What is the difference between the highest and the second highest Production index(2004-2006) in Middle income?
Keep it short and to the point. 1.04. What is the difference between the highest and the second highest Production index(2004-2006) in Antigua and Barbuda?
Provide a succinct answer. 1.07. What is the difference between the highest and the second highest Production index(2004-2006) in Suriname?
Your response must be concise. 3.65. What is the difference between the highest and the lowest Production index(2004-2006) in East Asia (all income levels)?
Your response must be concise. 14.53. What is the difference between the highest and the lowest Production index(2004-2006) in Middle income?
Provide a succinct answer. 11.37. What is the difference between the highest and the lowest Production index(2004-2006) of Antigua and Barbuda?
Give a very brief answer. 36.75. What is the difference between the highest and the lowest Production index(2004-2006) of Suriname?
Make the answer very short. 20.32. 